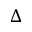Convert formula to latex. <formula><loc_0><loc_0><loc_500><loc_500>\Delta</formula> 